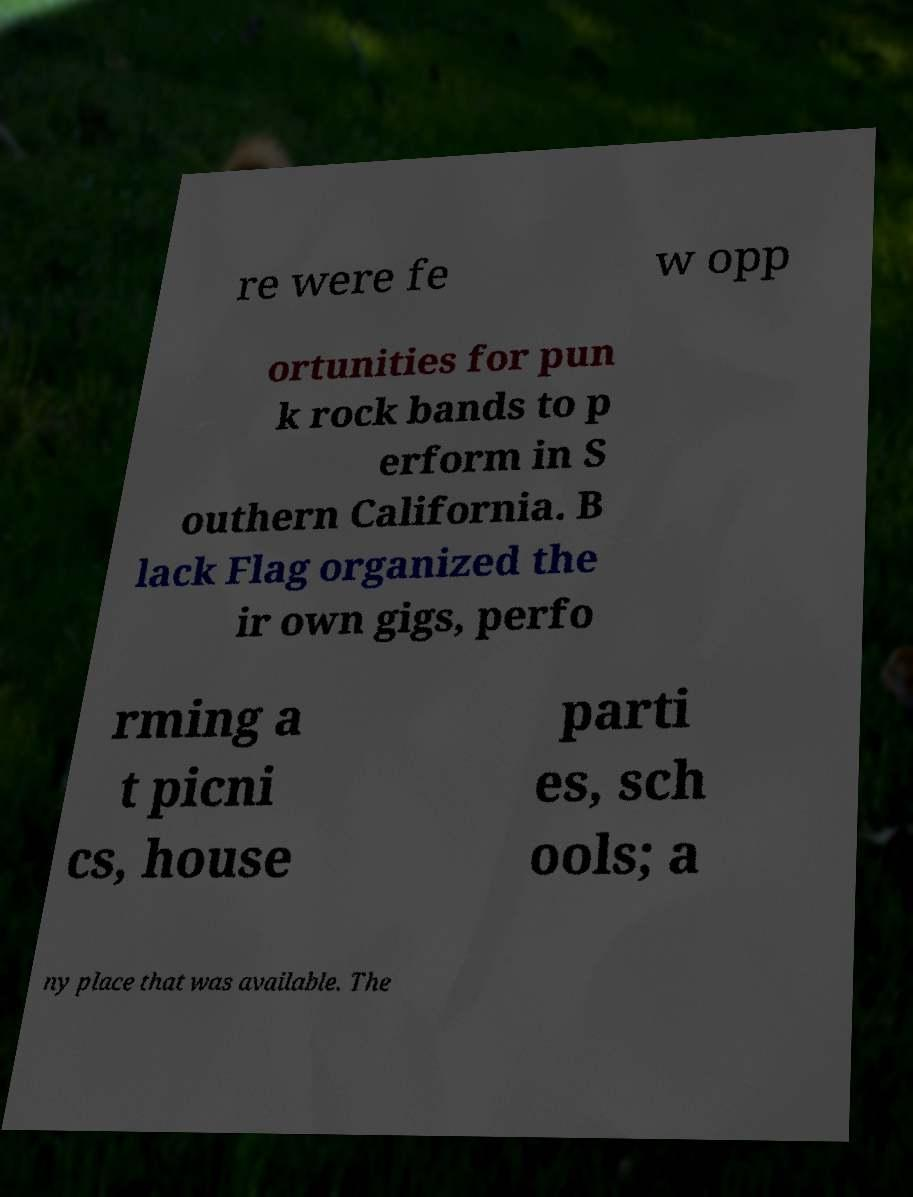Could you assist in decoding the text presented in this image and type it out clearly? re were fe w opp ortunities for pun k rock bands to p erform in S outhern California. B lack Flag organized the ir own gigs, perfo rming a t picni cs, house parti es, sch ools; a ny place that was available. The 